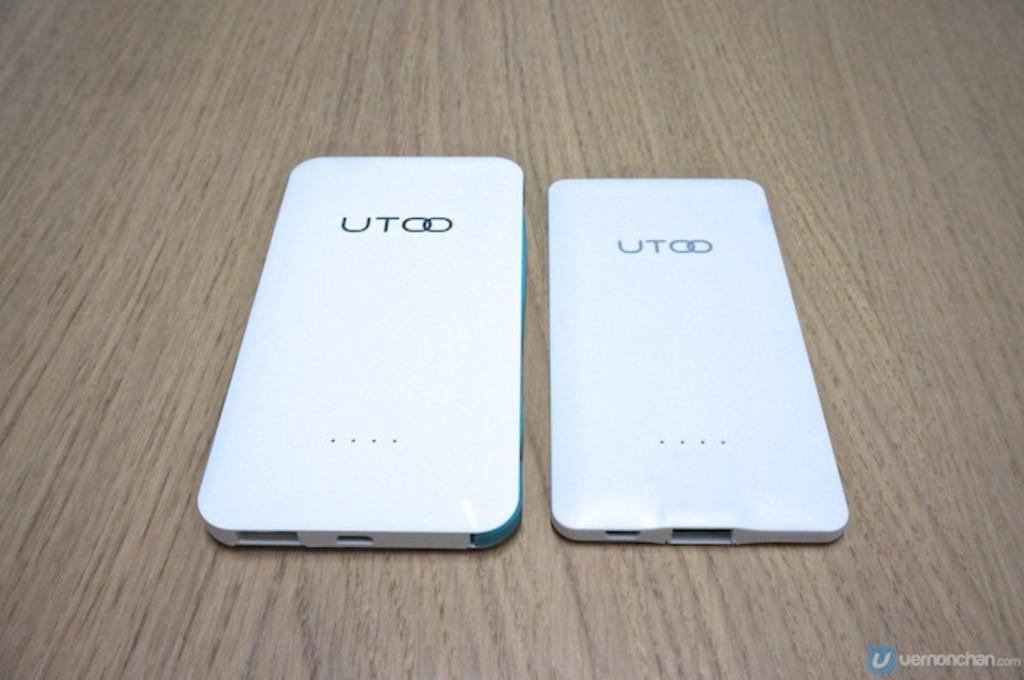Can you describe this image briefly? As we can see in the image there are two white color mobile phones on table. 